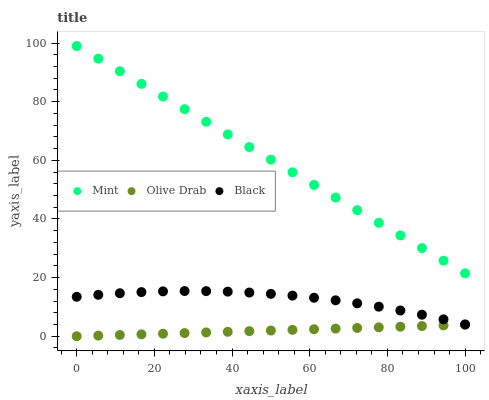Does Olive Drab have the minimum area under the curve?
Answer yes or no. Yes. Does Mint have the maximum area under the curve?
Answer yes or no. Yes. Does Mint have the minimum area under the curve?
Answer yes or no. No. Does Olive Drab have the maximum area under the curve?
Answer yes or no. No. Is Olive Drab the smoothest?
Answer yes or no. Yes. Is Black the roughest?
Answer yes or no. Yes. Is Mint the smoothest?
Answer yes or no. No. Is Mint the roughest?
Answer yes or no. No. Does Olive Drab have the lowest value?
Answer yes or no. Yes. Does Mint have the lowest value?
Answer yes or no. No. Does Mint have the highest value?
Answer yes or no. Yes. Does Olive Drab have the highest value?
Answer yes or no. No. Is Black less than Mint?
Answer yes or no. Yes. Is Black greater than Olive Drab?
Answer yes or no. Yes. Does Black intersect Mint?
Answer yes or no. No. 